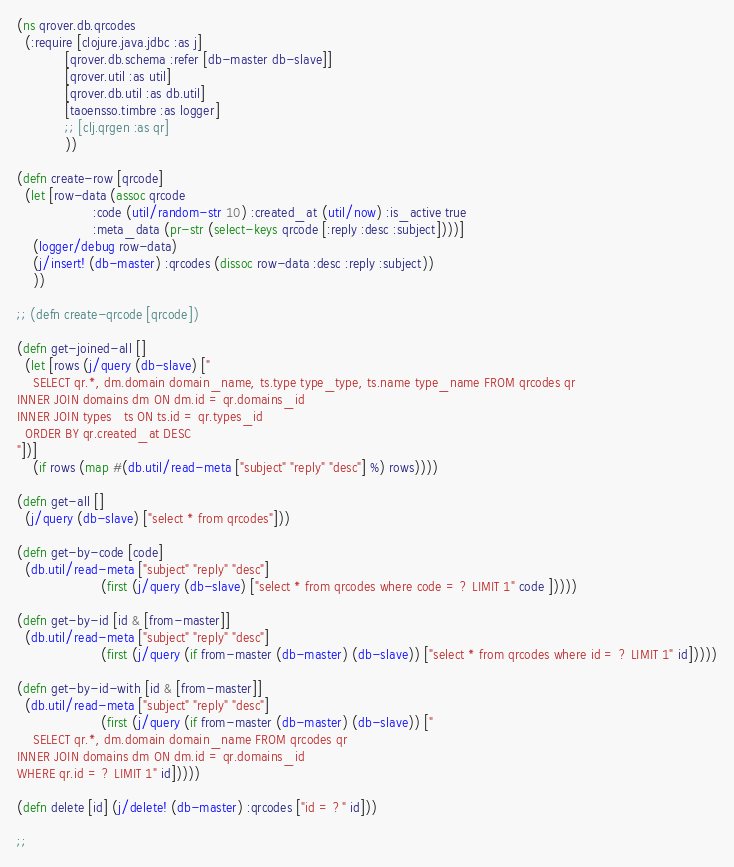Convert code to text. <code><loc_0><loc_0><loc_500><loc_500><_Clojure_>(ns qrover.db.qrcodes
  (:require [clojure.java.jdbc :as j]
            [qrover.db.schema :refer [db-master db-slave]]
            [qrover.util :as util]
            [qrover.db.util :as db.util]
            [taoensso.timbre :as logger]
            ;; [clj.qrgen :as qr]
            ))

(defn create-row [qrcode]
  (let [row-data (assoc qrcode
                   :code (util/random-str 10) :created_at (util/now) :is_active true
                   :meta_data (pr-str (select-keys qrcode [:reply :desc :subject])))]
    (logger/debug row-data)
    (j/insert! (db-master) :qrcodes (dissoc row-data :desc :reply :subject))
    ))

;; (defn create-qrcode [qrcode])

(defn get-joined-all []
  (let [rows (j/query (db-slave) ["
    SELECT qr.*, dm.domain domain_name, ts.type type_type, ts.name type_name FROM qrcodes qr
INNER JOIN domains dm ON dm.id = qr.domains_id
INNER JOIN types   ts ON ts.id = qr.types_id
  ORDER BY qr.created_at DESC
"])]
    (if rows (map #(db.util/read-meta ["subject" "reply" "desc"] %) rows))))

(defn get-all []
  (j/query (db-slave) ["select * from qrcodes"]))

(defn get-by-code [code]
  (db.util/read-meta ["subject" "reply" "desc"]
                     (first (j/query (db-slave) ["select * from qrcodes where code = ? LIMIT 1" code ]))))

(defn get-by-id [id & [from-master]]
  (db.util/read-meta ["subject" "reply" "desc"]
                     (first (j/query (if from-master (db-master) (db-slave)) ["select * from qrcodes where id = ? LIMIT 1" id]))))

(defn get-by-id-with [id & [from-master]]
  (db.util/read-meta ["subject" "reply" "desc"]
                     (first (j/query (if from-master (db-master) (db-slave)) ["
    SELECT qr.*, dm.domain domain_name FROM qrcodes qr
INNER JOIN domains dm ON dm.id = qr.domains_id
WHERE qr.id = ? LIMIT 1" id]))))

(defn delete [id] (j/delete! (db-master) :qrcodes ["id = ?" id]))

;;
</code> 